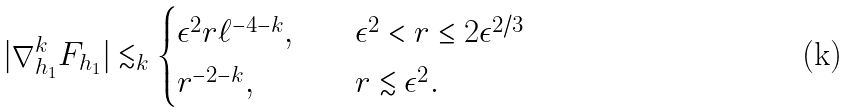Convert formula to latex. <formula><loc_0><loc_0><loc_500><loc_500>| \nabla ^ { k } _ { h _ { 1 } } F _ { h _ { 1 } } | \lesssim _ { k } \begin{cases} \epsilon ^ { 2 } r \ell ^ { - 4 - k } , \quad & \epsilon ^ { 2 } < r \leq 2 \epsilon ^ { 2 / 3 } \\ r ^ { - 2 - k } , \quad & r \lesssim \epsilon ^ { 2 } . \end{cases}</formula> 